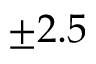<formula> <loc_0><loc_0><loc_500><loc_500>\pm 2 . 5</formula> 